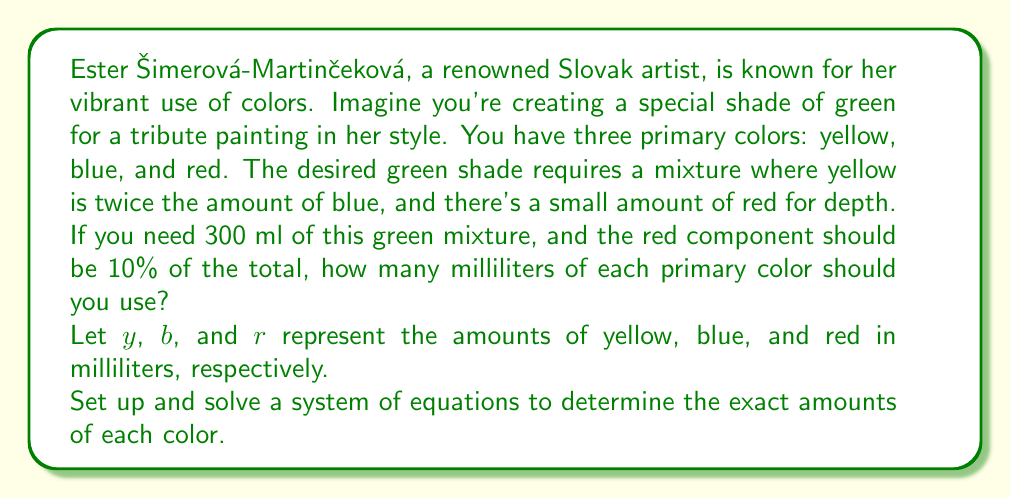What is the answer to this math problem? Let's approach this step-by-step:

1) First, we can set up our system of equations based on the given information:

   $$\begin{cases}
   y + b + r = 300 & \text{(total volume)} \\
   y = 2b & \text{(yellow is twice blue)} \\
   r = 0.1(300) = 30 & \text{(red is 10% of total)}
   \end{cases}$$

2) We already know $r = 30$ ml, so we can substitute this into the first equation:

   $$y + b + 30 = 300$$

3) Simplify:

   $$y + b = 270$$

4) Now, substitute $y = 2b$ into this equation:

   $$2b + b = 270$$
   $$3b = 270$$

5) Solve for $b$:

   $$b = 90$$

6) Since $y = 2b$, we can now find $y$:

   $$y = 2(90) = 180$$

7) Let's verify our solution:

   $$y + b + r = 180 + 90 + 30 = 300$$

   This confirms our solution is correct.
Answer: Yellow: 180 ml
Blue: 90 ml
Red: 30 ml 